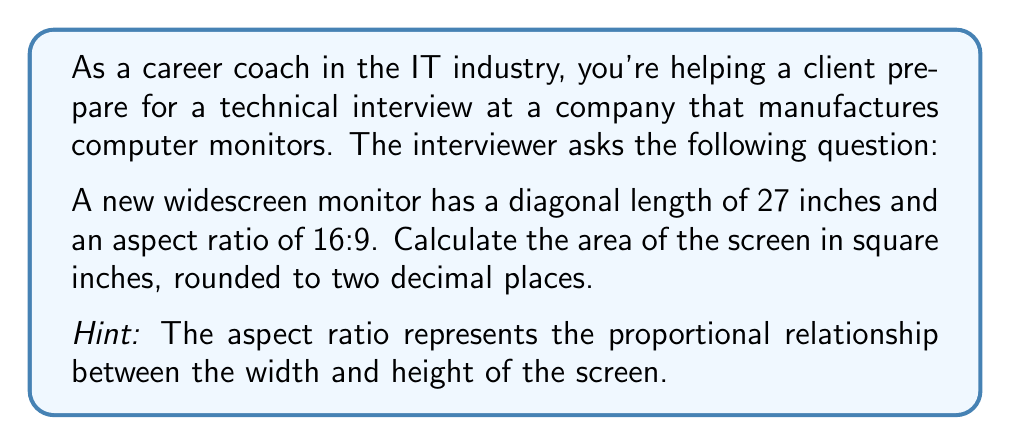Solve this math problem. Let's approach this step-by-step:

1) Let the width of the screen be $16x$ and the height be $9x$, where $x$ is some scaling factor.

2) We can use the Pythagorean theorem to relate these dimensions to the diagonal:

   $$(16x)^2 + (9x)^2 = 27^2$$

3) Simplify:

   $$256x^2 + 81x^2 = 729$$
   $$337x^2 = 729$$

4) Solve for $x$:

   $$x^2 = \frac{729}{337}$$
   $$x = \sqrt{\frac{729}{337}} \approx 1.4704$$

5) Now we can calculate the width and height:

   Width = $16x = 16 * 1.4704 = 23.5264$ inches
   Height = $9x = 9 * 1.4704 = 13.2336$ inches

6) The area of the screen is width * height:

   Area = $23.5264 * 13.2336 = 311.3095$ square inches

7) Rounding to two decimal places:

   Area ≈ 311.31 square inches

This problem demonstrates the application of geometry and algebra in real-world technology scenarios, which is relevant for IT professionals.
Answer: 311.31 square inches 